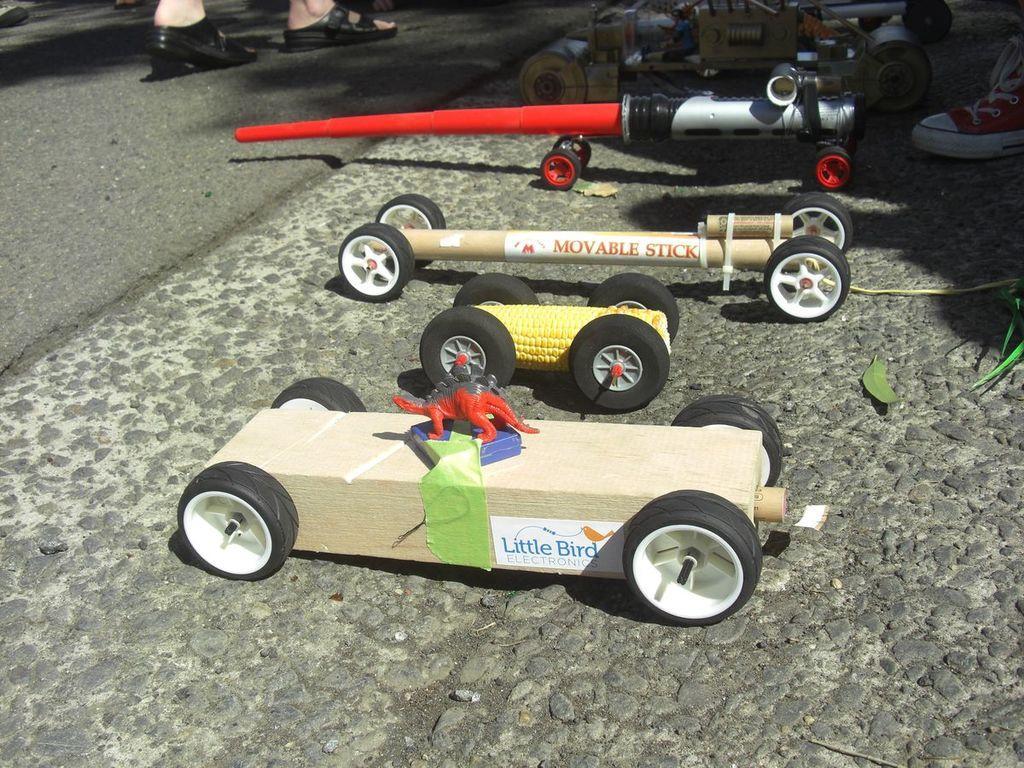Could you give a brief overview of what you see in this image? In the foreground of this image, there are man made motor vehicles on the road and we can also see legs of few persons on the left and the right. 